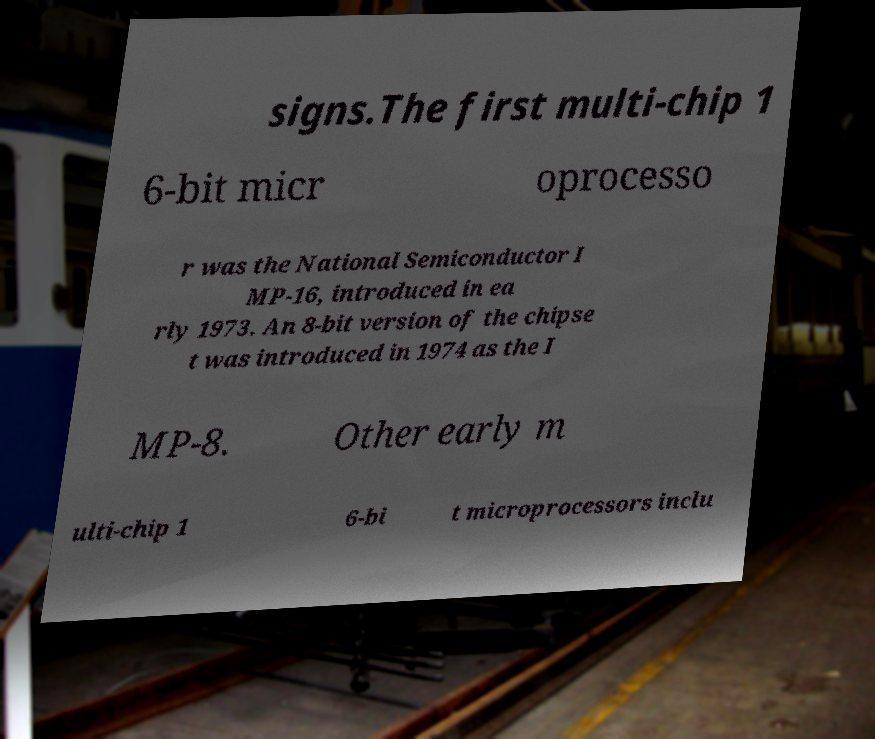Could you extract and type out the text from this image? signs.The first multi-chip 1 6-bit micr oprocesso r was the National Semiconductor I MP-16, introduced in ea rly 1973. An 8-bit version of the chipse t was introduced in 1974 as the I MP-8. Other early m ulti-chip 1 6-bi t microprocessors inclu 